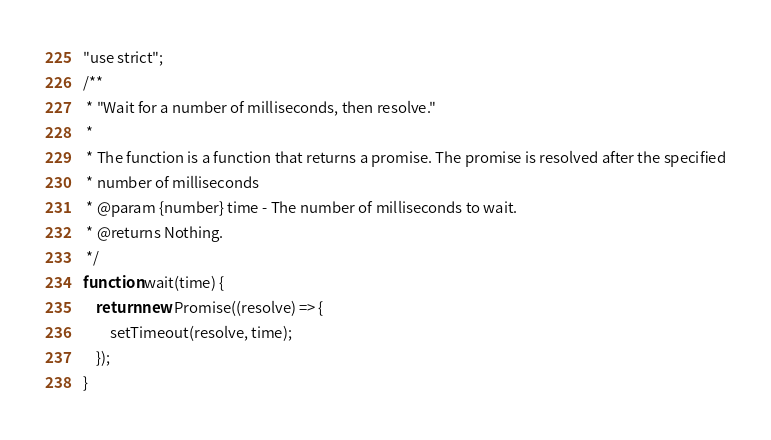<code> <loc_0><loc_0><loc_500><loc_500><_JavaScript_>"use strict";
/**
 * "Wait for a number of milliseconds, then resolve."
 *
 * The function is a function that returns a promise. The promise is resolved after the specified
 * number of milliseconds
 * @param {number} time - The number of milliseconds to wait.
 * @returns Nothing.
 */
function wait(time) {
    return new Promise((resolve) => {
        setTimeout(resolve, time);
    });
}
</code> 